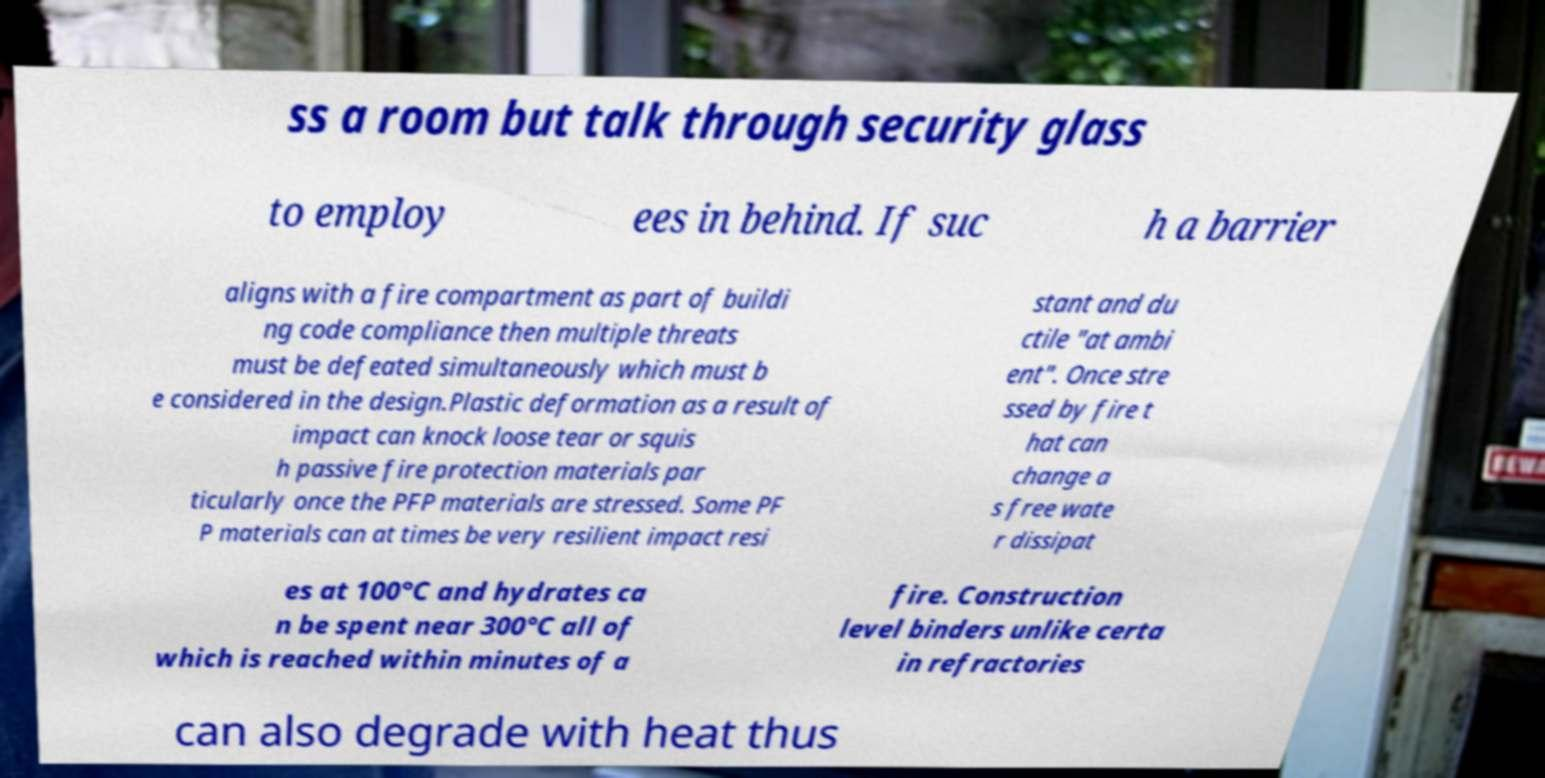Can you read and provide the text displayed in the image?This photo seems to have some interesting text. Can you extract and type it out for me? ss a room but talk through security glass to employ ees in behind. If suc h a barrier aligns with a fire compartment as part of buildi ng code compliance then multiple threats must be defeated simultaneously which must b e considered in the design.Plastic deformation as a result of impact can knock loose tear or squis h passive fire protection materials par ticularly once the PFP materials are stressed. Some PF P materials can at times be very resilient impact resi stant and du ctile "at ambi ent". Once stre ssed by fire t hat can change a s free wate r dissipat es at 100°C and hydrates ca n be spent near 300°C all of which is reached within minutes of a fire. Construction level binders unlike certa in refractories can also degrade with heat thus 